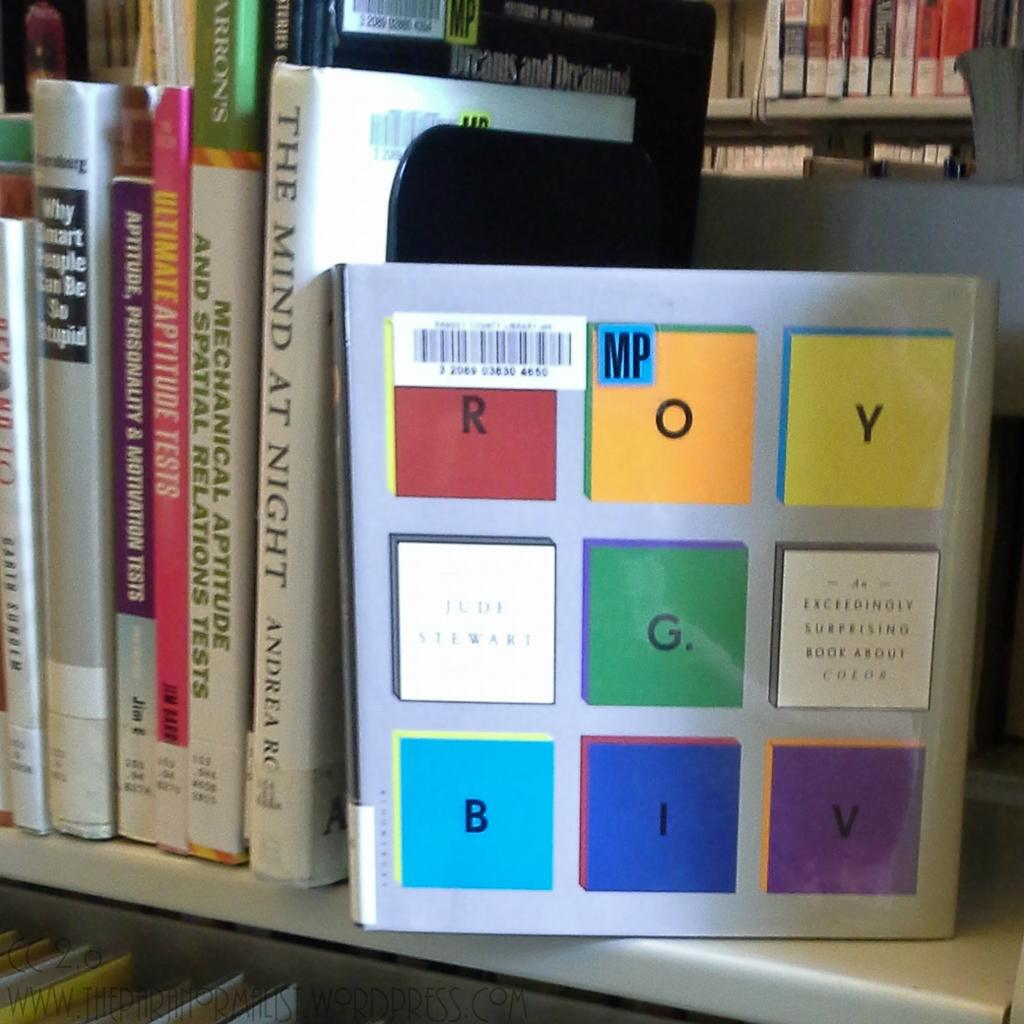<image>
Offer a succinct explanation of the picture presented. The Mind at Night, was right next to a book that was about colors. 